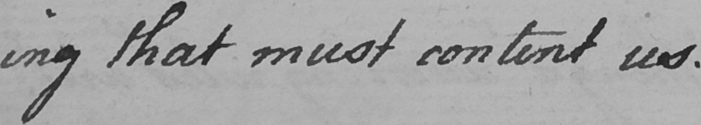Please provide the text content of this handwritten line. ing that must content us . 